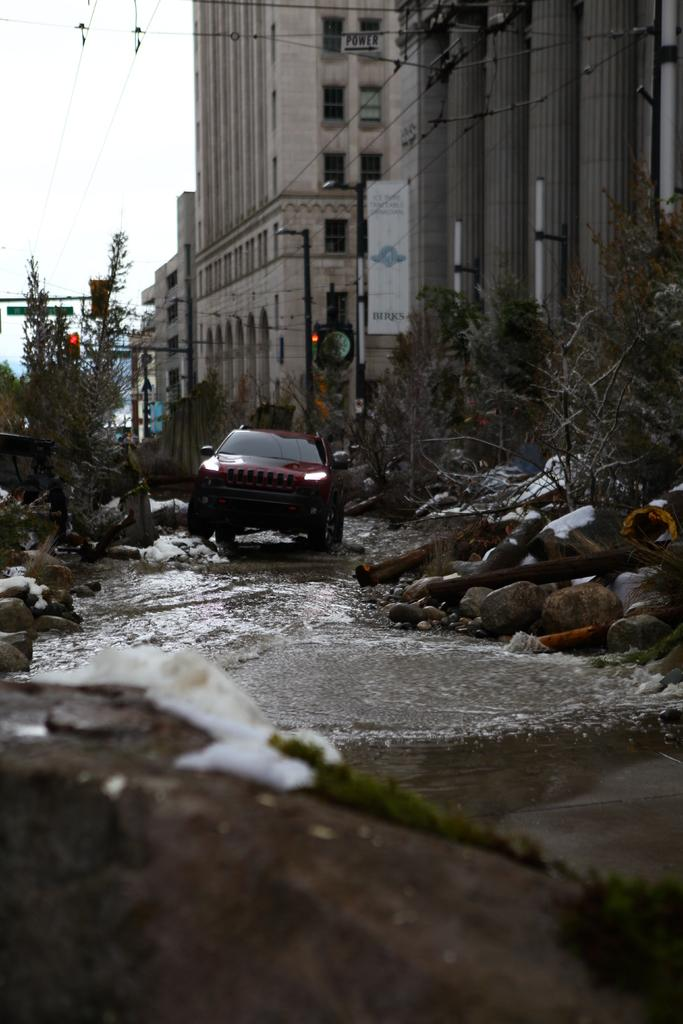What is the main subject of the image? The main subject of the image is a car on the road. What can be seen in the background of the image? The sky is visible in the background of the image. What type of structures are present in the image? There are buildings in the image. What other objects can be seen in the image? There are trees, poles, and stones in the image. Can you tell me the hour at which the receipt was requested in the image? There is no receipt or request for a receipt present in the image. 